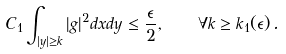Convert formula to latex. <formula><loc_0><loc_0><loc_500><loc_500>C _ { 1 } \int _ { | y | \geq k } | g | ^ { 2 } d x d y \leq \frac { \epsilon } { 2 } , \quad \forall k \geq k _ { 1 } ( \epsilon ) \, .</formula> 